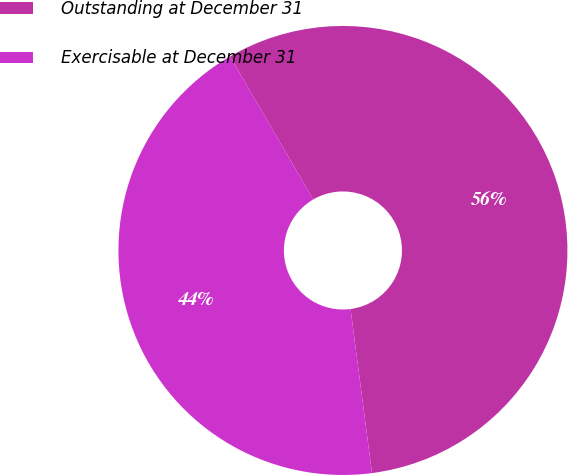<chart> <loc_0><loc_0><loc_500><loc_500><pie_chart><fcel>Outstanding at December 31<fcel>Exercisable at December 31<nl><fcel>56.32%<fcel>43.68%<nl></chart> 